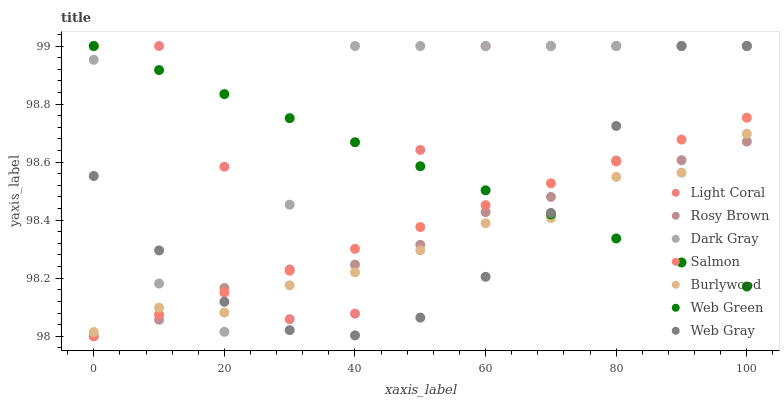Does Burlywood have the minimum area under the curve?
Answer yes or no. Yes. Does Dark Gray have the maximum area under the curve?
Answer yes or no. Yes. Does Web Gray have the minimum area under the curve?
Answer yes or no. No. Does Web Gray have the maximum area under the curve?
Answer yes or no. No. Is Web Green the smoothest?
Answer yes or no. Yes. Is Light Coral the roughest?
Answer yes or no. Yes. Is Web Gray the smoothest?
Answer yes or no. No. Is Web Gray the roughest?
Answer yes or no. No. Does Rosy Brown have the lowest value?
Answer yes or no. Yes. Does Web Gray have the lowest value?
Answer yes or no. No. Does Light Coral have the highest value?
Answer yes or no. Yes. Does Burlywood have the highest value?
Answer yes or no. No. Does Dark Gray intersect Web Green?
Answer yes or no. Yes. Is Dark Gray less than Web Green?
Answer yes or no. No. Is Dark Gray greater than Web Green?
Answer yes or no. No. 